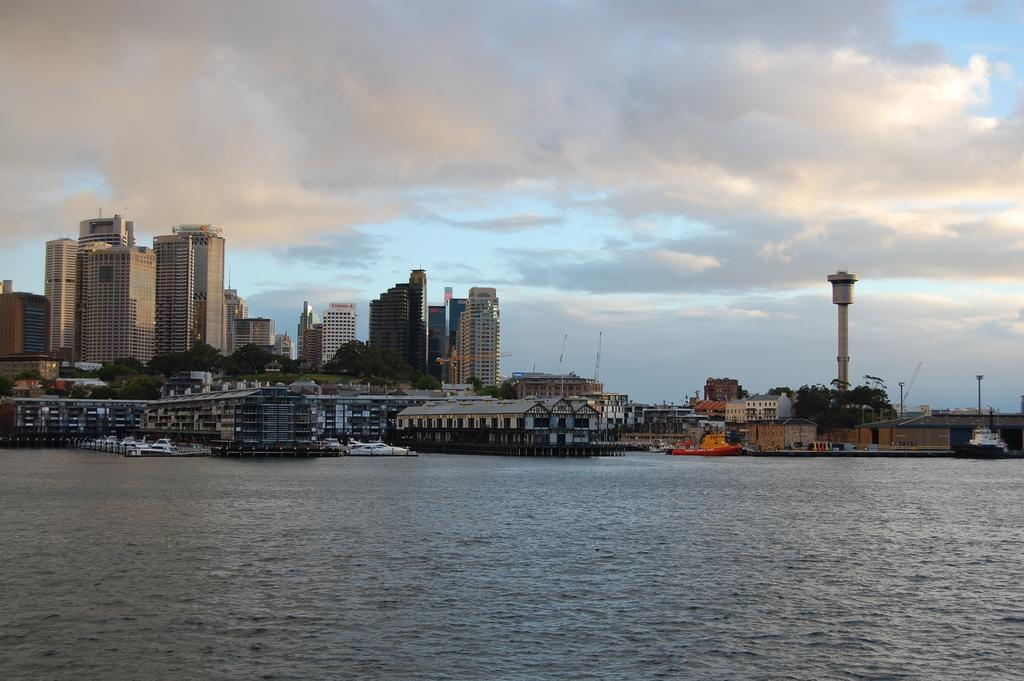What is the main subject of the image? The main subject of the image is water. What is present on the water in the image? There are boats on the water. What type of structures can be seen on the left side of the image? There are big buildings on the left side of the image. What is visible at the top of the image? The sky is visible at the top of the image. Can you see any quicksand in the image? There is no quicksand present in the image. What type of thread is being used to tie the boats together in the image? There is no thread visible in the image, and the boats are not tied together. 